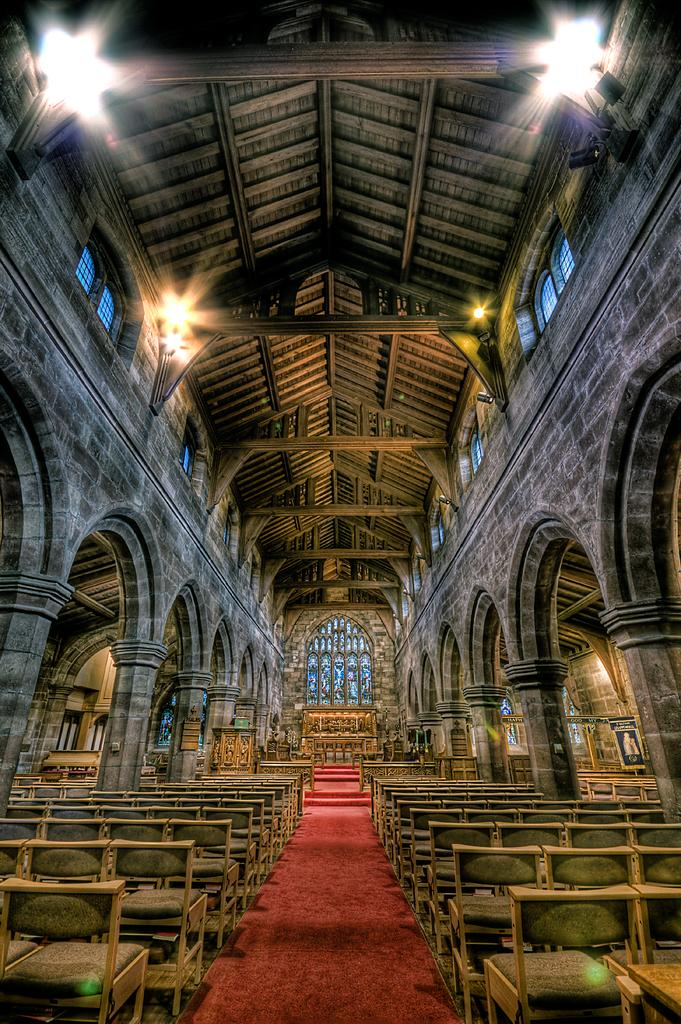What type of location is depicted in the image? The image is an inside view of a building. What type of furniture is present in the image? There are chairs in the image. What type of soft furnishings are present in the image? There are pillows in the image. What type of lighting is present in the image? There are lights in the image. What position does the committee hold in the image? There is no committee present in the image. What type of cream is being used to clean the chairs in the image? There is no cream being used to clean the chairs in the image. 